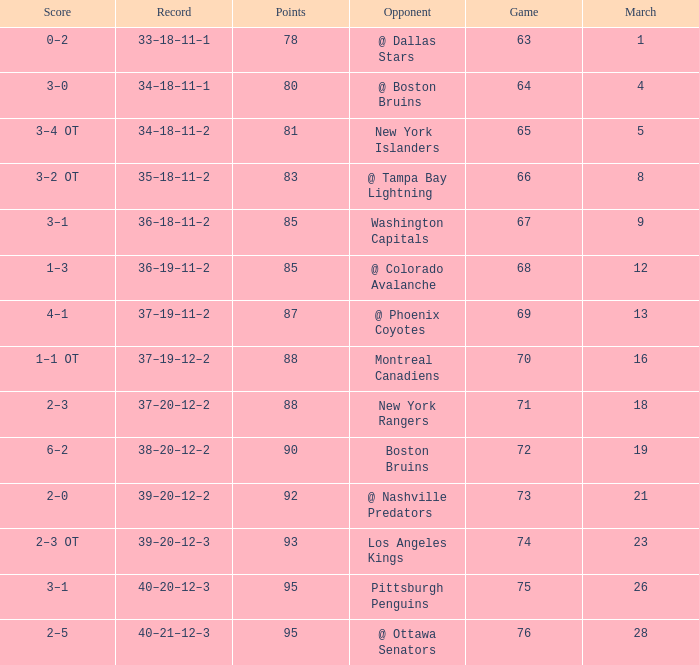Which Game is the highest one that has Points smaller than 92, and a Score of 1–3? 68.0. 